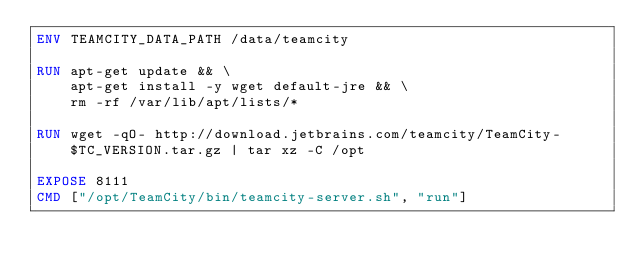Convert code to text. <code><loc_0><loc_0><loc_500><loc_500><_Dockerfile_>ENV TEAMCITY_DATA_PATH /data/teamcity

RUN	apt-get update && \
		apt-get install -y wget default-jre && \
		rm -rf /var/lib/apt/lists/*

RUN wget -qO- http://download.jetbrains.com/teamcity/TeamCity-$TC_VERSION.tar.gz | tar xz -C /opt

EXPOSE 8111
CMD ["/opt/TeamCity/bin/teamcity-server.sh", "run"]
</code> 